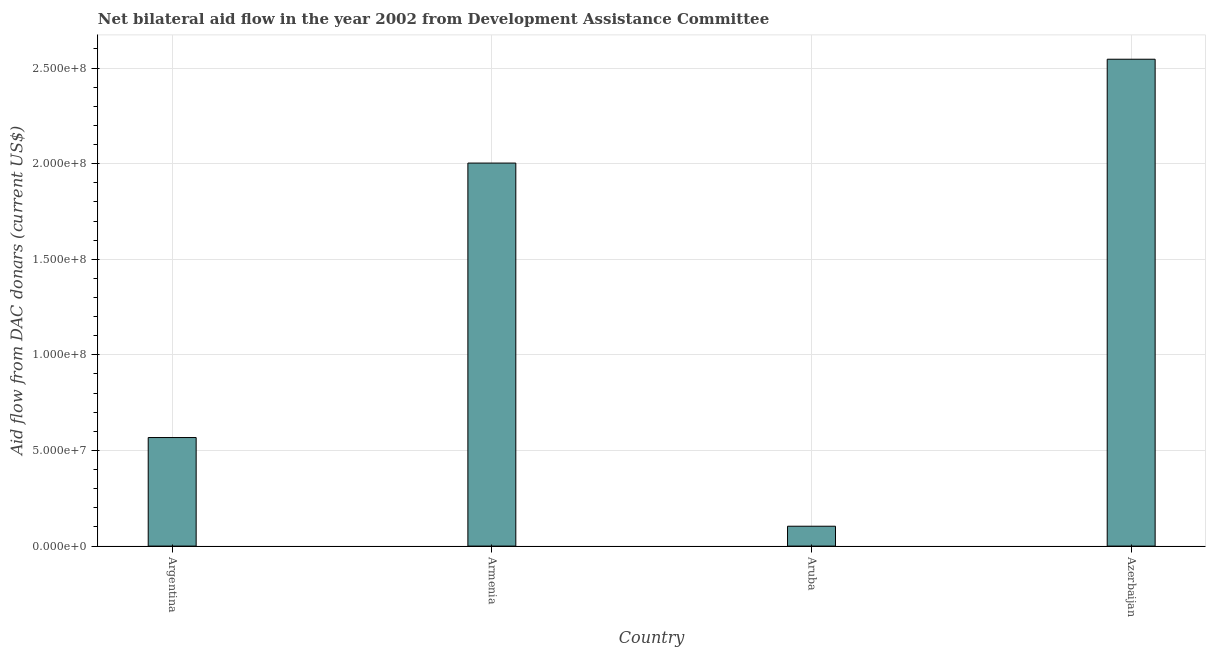Does the graph contain grids?
Make the answer very short. Yes. What is the title of the graph?
Provide a short and direct response. Net bilateral aid flow in the year 2002 from Development Assistance Committee. What is the label or title of the X-axis?
Make the answer very short. Country. What is the label or title of the Y-axis?
Your answer should be very brief. Aid flow from DAC donars (current US$). What is the net bilateral aid flows from dac donors in Armenia?
Provide a succinct answer. 2.00e+08. Across all countries, what is the maximum net bilateral aid flows from dac donors?
Your answer should be very brief. 2.55e+08. Across all countries, what is the minimum net bilateral aid flows from dac donors?
Offer a very short reply. 1.04e+07. In which country was the net bilateral aid flows from dac donors maximum?
Offer a very short reply. Azerbaijan. In which country was the net bilateral aid flows from dac donors minimum?
Provide a short and direct response. Aruba. What is the sum of the net bilateral aid flows from dac donors?
Ensure brevity in your answer.  5.22e+08. What is the difference between the net bilateral aid flows from dac donors in Aruba and Azerbaijan?
Your answer should be very brief. -2.44e+08. What is the average net bilateral aid flows from dac donors per country?
Ensure brevity in your answer.  1.31e+08. What is the median net bilateral aid flows from dac donors?
Ensure brevity in your answer.  1.29e+08. What is the ratio of the net bilateral aid flows from dac donors in Armenia to that in Aruba?
Your answer should be very brief. 19.28. Is the difference between the net bilateral aid flows from dac donors in Argentina and Armenia greater than the difference between any two countries?
Give a very brief answer. No. What is the difference between the highest and the second highest net bilateral aid flows from dac donors?
Provide a succinct answer. 5.43e+07. What is the difference between the highest and the lowest net bilateral aid flows from dac donors?
Provide a short and direct response. 2.44e+08. In how many countries, is the net bilateral aid flows from dac donors greater than the average net bilateral aid flows from dac donors taken over all countries?
Offer a terse response. 2. How many bars are there?
Your answer should be compact. 4. Are all the bars in the graph horizontal?
Keep it short and to the point. No. How many countries are there in the graph?
Provide a succinct answer. 4. What is the Aid flow from DAC donars (current US$) in Argentina?
Provide a short and direct response. 5.68e+07. What is the Aid flow from DAC donars (current US$) in Armenia?
Make the answer very short. 2.00e+08. What is the Aid flow from DAC donars (current US$) in Aruba?
Your answer should be very brief. 1.04e+07. What is the Aid flow from DAC donars (current US$) of Azerbaijan?
Keep it short and to the point. 2.55e+08. What is the difference between the Aid flow from DAC donars (current US$) in Argentina and Armenia?
Keep it short and to the point. -1.44e+08. What is the difference between the Aid flow from DAC donars (current US$) in Argentina and Aruba?
Your response must be concise. 4.64e+07. What is the difference between the Aid flow from DAC donars (current US$) in Argentina and Azerbaijan?
Offer a terse response. -1.98e+08. What is the difference between the Aid flow from DAC donars (current US$) in Armenia and Aruba?
Offer a very short reply. 1.90e+08. What is the difference between the Aid flow from DAC donars (current US$) in Armenia and Azerbaijan?
Offer a very short reply. -5.43e+07. What is the difference between the Aid flow from DAC donars (current US$) in Aruba and Azerbaijan?
Ensure brevity in your answer.  -2.44e+08. What is the ratio of the Aid flow from DAC donars (current US$) in Argentina to that in Armenia?
Your answer should be compact. 0.28. What is the ratio of the Aid flow from DAC donars (current US$) in Argentina to that in Aruba?
Your response must be concise. 5.46. What is the ratio of the Aid flow from DAC donars (current US$) in Argentina to that in Azerbaijan?
Provide a succinct answer. 0.22. What is the ratio of the Aid flow from DAC donars (current US$) in Armenia to that in Aruba?
Offer a terse response. 19.28. What is the ratio of the Aid flow from DAC donars (current US$) in Armenia to that in Azerbaijan?
Provide a short and direct response. 0.79. What is the ratio of the Aid flow from DAC donars (current US$) in Aruba to that in Azerbaijan?
Your response must be concise. 0.04. 